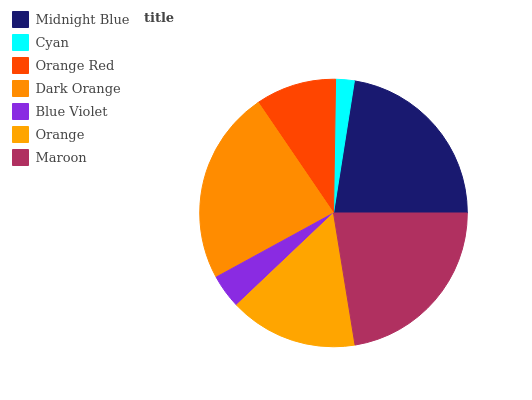Is Cyan the minimum?
Answer yes or no. Yes. Is Dark Orange the maximum?
Answer yes or no. Yes. Is Orange Red the minimum?
Answer yes or no. No. Is Orange Red the maximum?
Answer yes or no. No. Is Orange Red greater than Cyan?
Answer yes or no. Yes. Is Cyan less than Orange Red?
Answer yes or no. Yes. Is Cyan greater than Orange Red?
Answer yes or no. No. Is Orange Red less than Cyan?
Answer yes or no. No. Is Orange the high median?
Answer yes or no. Yes. Is Orange the low median?
Answer yes or no. Yes. Is Dark Orange the high median?
Answer yes or no. No. Is Cyan the low median?
Answer yes or no. No. 